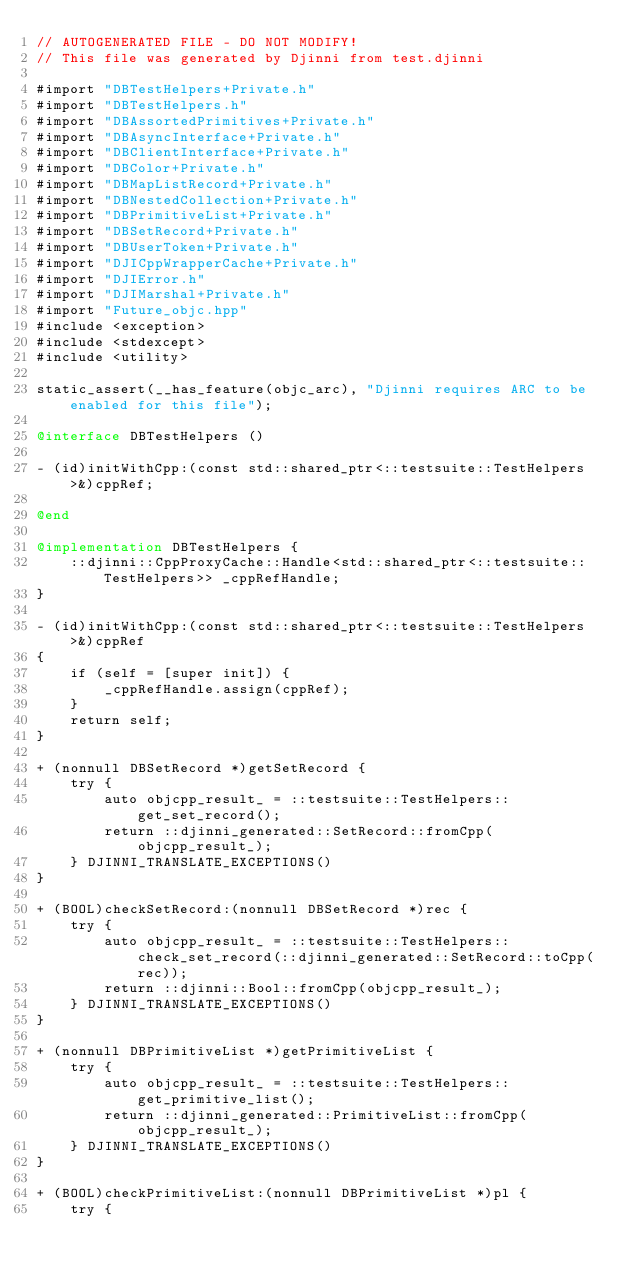Convert code to text. <code><loc_0><loc_0><loc_500><loc_500><_ObjectiveC_>// AUTOGENERATED FILE - DO NOT MODIFY!
// This file was generated by Djinni from test.djinni

#import "DBTestHelpers+Private.h"
#import "DBTestHelpers.h"
#import "DBAssortedPrimitives+Private.h"
#import "DBAsyncInterface+Private.h"
#import "DBClientInterface+Private.h"
#import "DBColor+Private.h"
#import "DBMapListRecord+Private.h"
#import "DBNestedCollection+Private.h"
#import "DBPrimitiveList+Private.h"
#import "DBSetRecord+Private.h"
#import "DBUserToken+Private.h"
#import "DJICppWrapperCache+Private.h"
#import "DJIError.h"
#import "DJIMarshal+Private.h"
#import "Future_objc.hpp"
#include <exception>
#include <stdexcept>
#include <utility>

static_assert(__has_feature(objc_arc), "Djinni requires ARC to be enabled for this file");

@interface DBTestHelpers ()

- (id)initWithCpp:(const std::shared_ptr<::testsuite::TestHelpers>&)cppRef;

@end

@implementation DBTestHelpers {
    ::djinni::CppProxyCache::Handle<std::shared_ptr<::testsuite::TestHelpers>> _cppRefHandle;
}

- (id)initWithCpp:(const std::shared_ptr<::testsuite::TestHelpers>&)cppRef
{
    if (self = [super init]) {
        _cppRefHandle.assign(cppRef);
    }
    return self;
}

+ (nonnull DBSetRecord *)getSetRecord {
    try {
        auto objcpp_result_ = ::testsuite::TestHelpers::get_set_record();
        return ::djinni_generated::SetRecord::fromCpp(objcpp_result_);
    } DJINNI_TRANSLATE_EXCEPTIONS()
}

+ (BOOL)checkSetRecord:(nonnull DBSetRecord *)rec {
    try {
        auto objcpp_result_ = ::testsuite::TestHelpers::check_set_record(::djinni_generated::SetRecord::toCpp(rec));
        return ::djinni::Bool::fromCpp(objcpp_result_);
    } DJINNI_TRANSLATE_EXCEPTIONS()
}

+ (nonnull DBPrimitiveList *)getPrimitiveList {
    try {
        auto objcpp_result_ = ::testsuite::TestHelpers::get_primitive_list();
        return ::djinni_generated::PrimitiveList::fromCpp(objcpp_result_);
    } DJINNI_TRANSLATE_EXCEPTIONS()
}

+ (BOOL)checkPrimitiveList:(nonnull DBPrimitiveList *)pl {
    try {</code> 